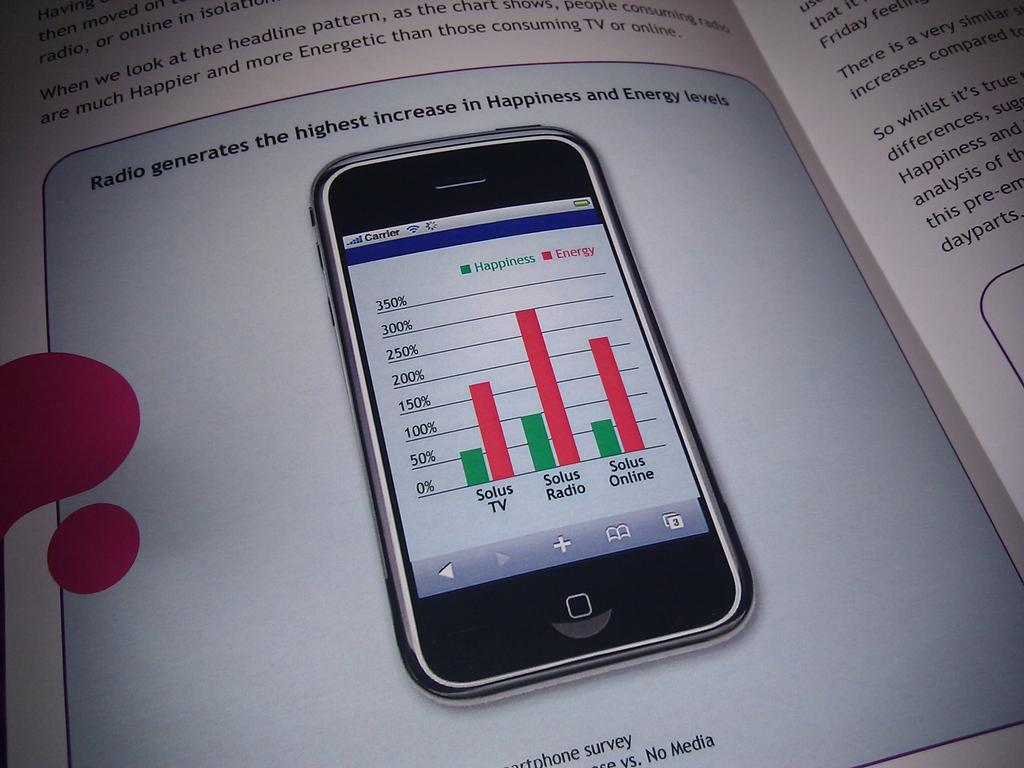Provide a one-sentence caption for the provided image. an ad for a cell phone saying "Radio generates the highest increase in Happiness". 